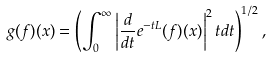<formula> <loc_0><loc_0><loc_500><loc_500>g ( f ) ( x ) = \left ( \int _ { 0 } ^ { \infty } \left | \frac { d } { d t } e ^ { - t L } ( f ) ( x ) \right | ^ { 2 } t d t \right ) ^ { 1 / 2 } ,</formula> 